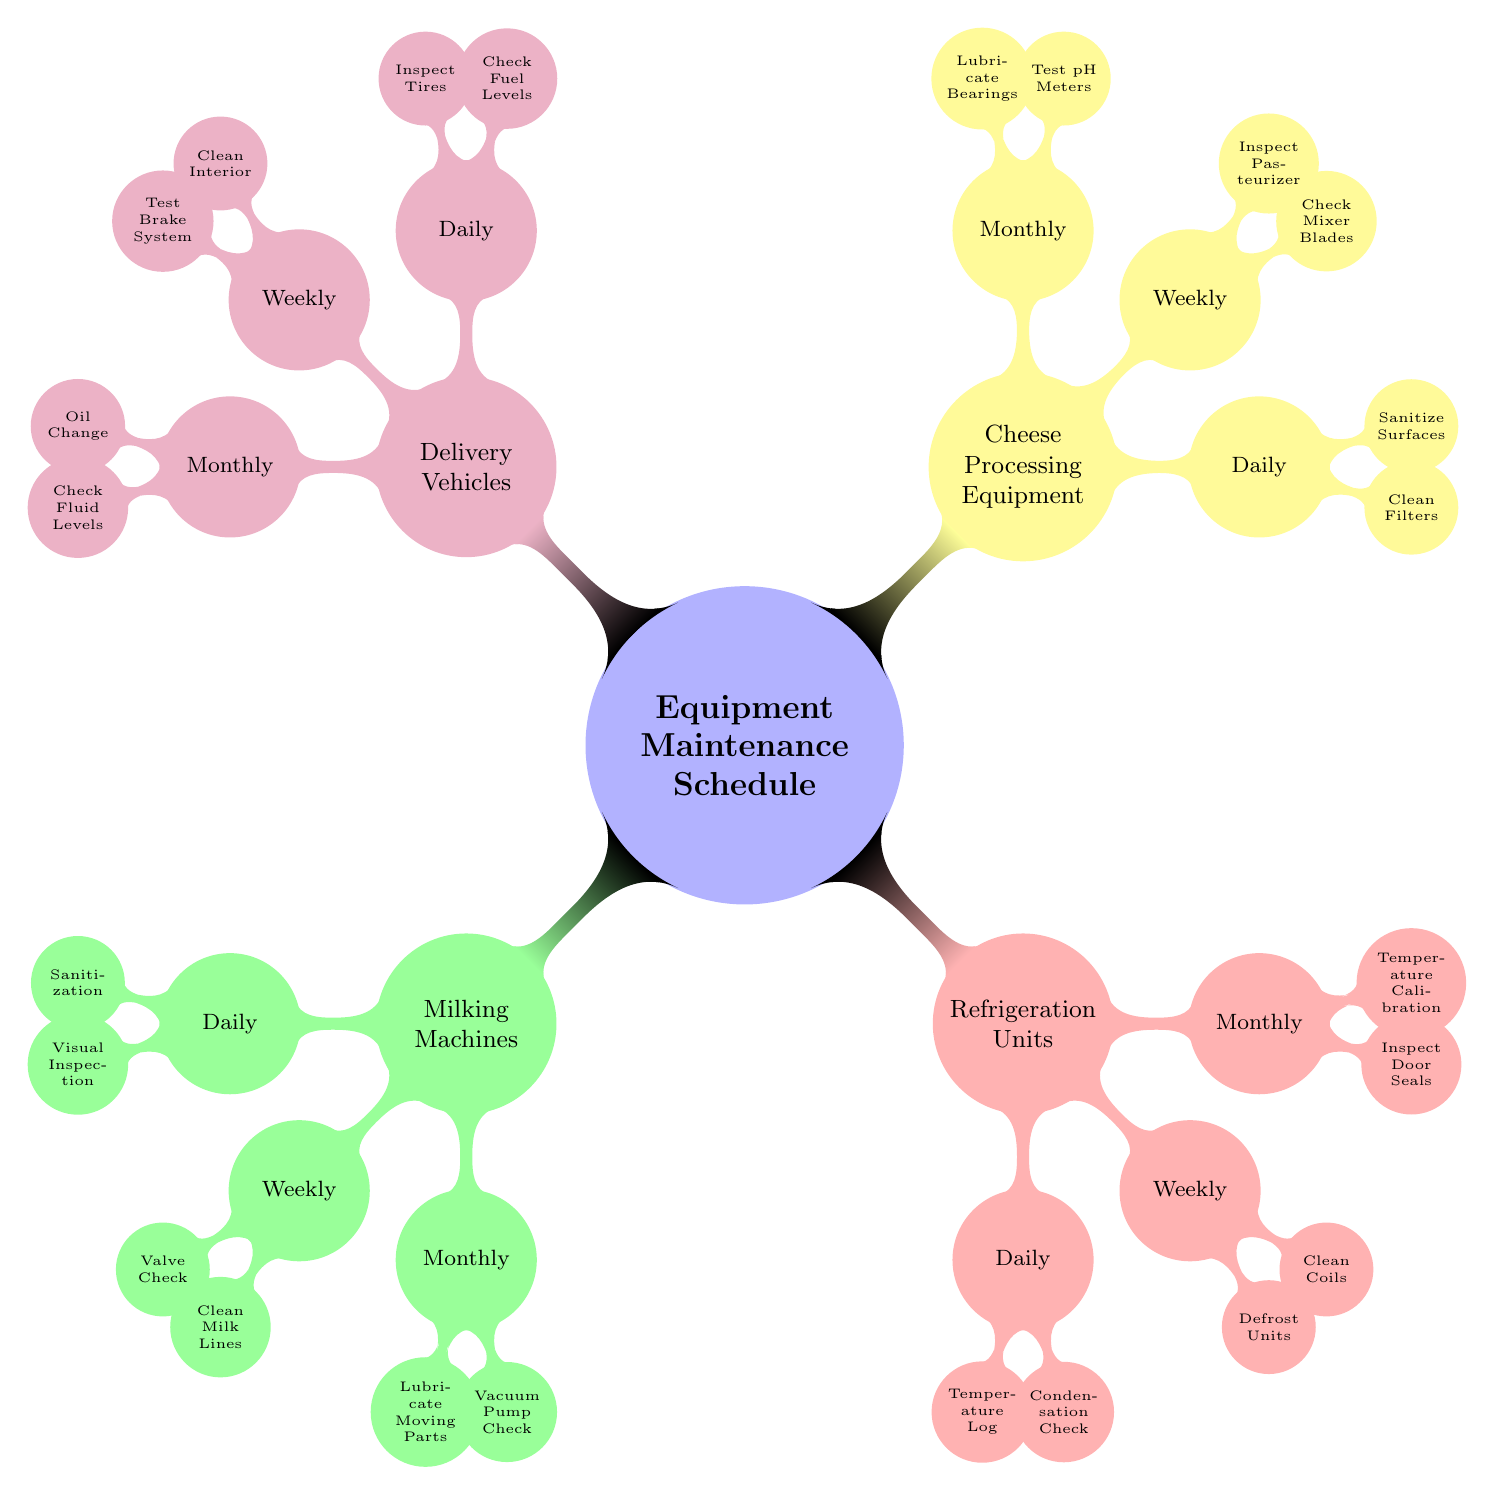What types of equipment are included in the maintenance schedule? The main categories of equipment listed in the diagram are Milking Machines, Refrigeration Units, Cheese Processing Equipment, and Delivery Vehicles.
Answer: Milking Machines, Refrigeration Units, Cheese Processing Equipment, Delivery Vehicles How many maintenance activities are listed for Refrigeration Units? The diagram shows that there are three categories of maintenance activities (Daily, Weekly, and Monthly) for Refrigeration Units, and each category has two activities. Therefore, there are a total of 6 maintenance activities.
Answer: 6 What is the daily maintenance activity for Cheese Processing Equipment? According to the diagram, the daily maintenance activities for Cheese Processing Equipment are clean filters and sanitize surfaces.
Answer: Clean Filters, Sanitize Surfaces Which equipment requires a monthly "Oil Change"? By examining the diagram, the monthly maintenance activity "Oil Change" is listed under Delivery Vehicles.
Answer: Delivery Vehicles How many weekly maintenance tasks are specified for Milking Machines? The Milking Machines category has two weekly maintenance tasks: Valve Check and Clean Milk Lines. Thus, the total is 2 tasks.
Answer: 2 What maintenance activities are scheduled monthly for Refrigeration Units? The diagram indicates that the monthly maintenance activities for Refrigeration Units include Inspect Door Seals and Temperature Calibration.
Answer: Inspect Door Seals, Temperature Calibration Which equipment type has the most daily maintenance tasks? When comparing the daily maintenance tasks across the different equipment types, Milking Machines, Refrigeration Units, Cheese Processing Equipment, and Delivery Vehicles each have two daily tasks. Therefore, they all have the same amount.
Answer: All have the same amount What is the first activity listed for Delivery Vehicles? The first activity under Delivery Vehicles for daily maintenance is "Check Fuel Levels." This can be seen by following the nodes in that section of the diagram.
Answer: Check Fuel Levels 